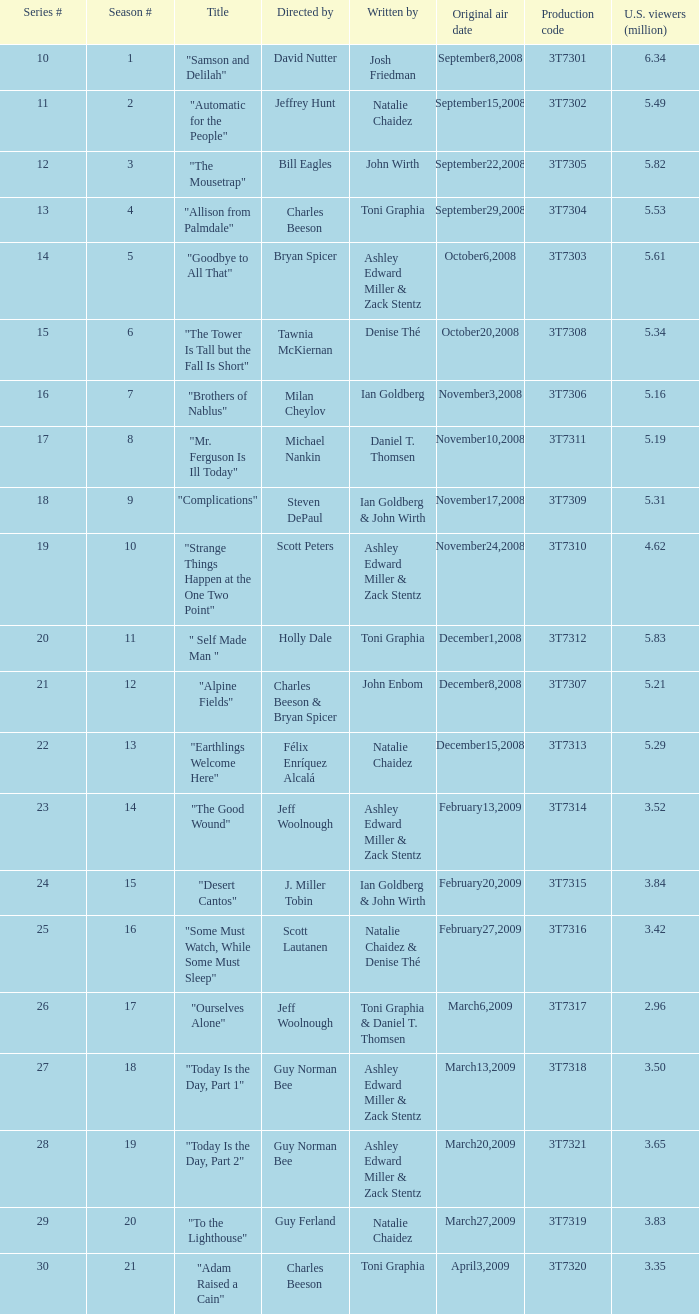Which episode number drew in 3.84 million viewers in the U.S.? 24.0. 